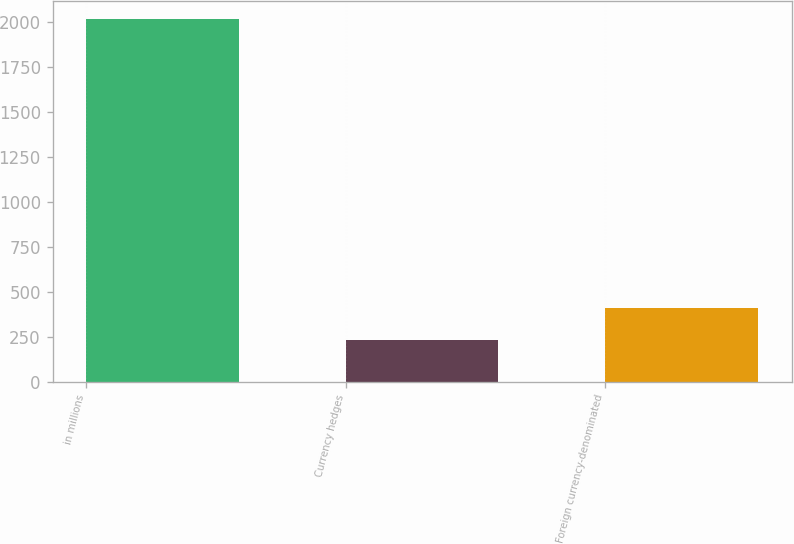Convert chart. <chart><loc_0><loc_0><loc_500><loc_500><bar_chart><fcel>in millions<fcel>Currency hedges<fcel>Foreign currency-denominated<nl><fcel>2012<fcel>233<fcel>410.9<nl></chart> 